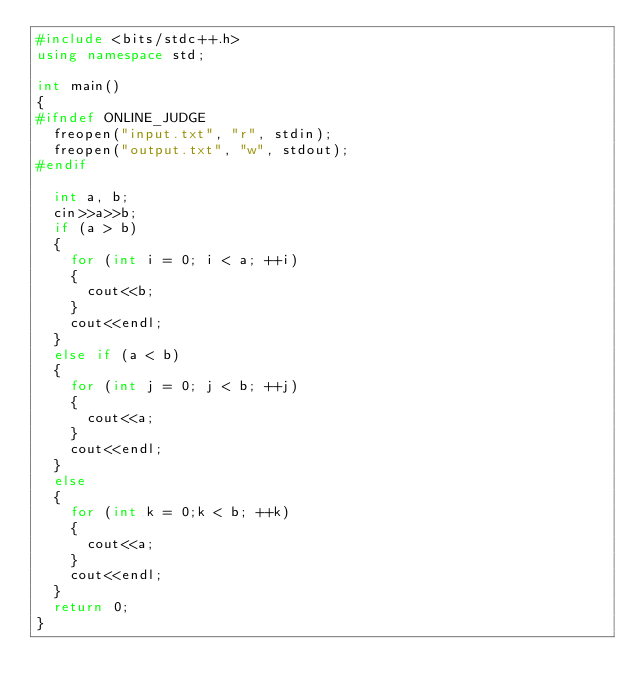Convert code to text. <code><loc_0><loc_0><loc_500><loc_500><_C++_>#include <bits/stdc++.h>
using namespace std;

int main()
{
#ifndef ONLINE_JUDGE
	freopen("input.txt", "r", stdin);
	freopen("output.txt", "w", stdout);
#endif

	int a, b;
	cin>>a>>b;
	if (a > b)
	{
		for (int i = 0; i < a; ++i)
		{
			cout<<b;
		}
		cout<<endl;
	}
	else if (a < b)
	{
		for (int j = 0; j < b; ++j)
		{
			cout<<a;
		}
		cout<<endl;
	}
	else
	{
		for (int k = 0;k < b; ++k)
		{
			cout<<a;
		}
		cout<<endl;
	}
	return 0;
}</code> 